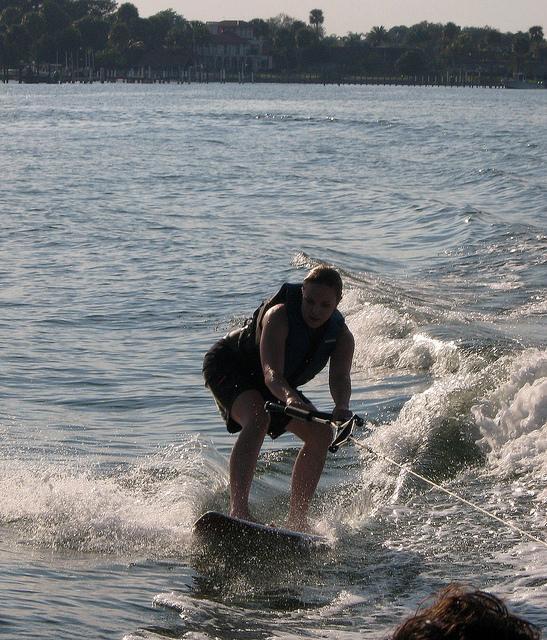What is the name of the safety garment the wakeboarder is wearing?
Answer the question by selecting the correct answer among the 4 following choices and explain your choice with a short sentence. The answer should be formatted with the following format: `Answer: choice
Rationale: rationale.`
Options: Shin guards, helmet, glasses, life vest. Answer: life vest.
Rationale: The safety harness around his chest is usually given this name. What form of exercise is this?
Choose the right answer and clarify with the format: 'Answer: answer
Rationale: rationale.'
Options: Jet skiing, surfboarding, water skiing, water boarding. Answer: water skiing.
Rationale: The person is water skiing. 